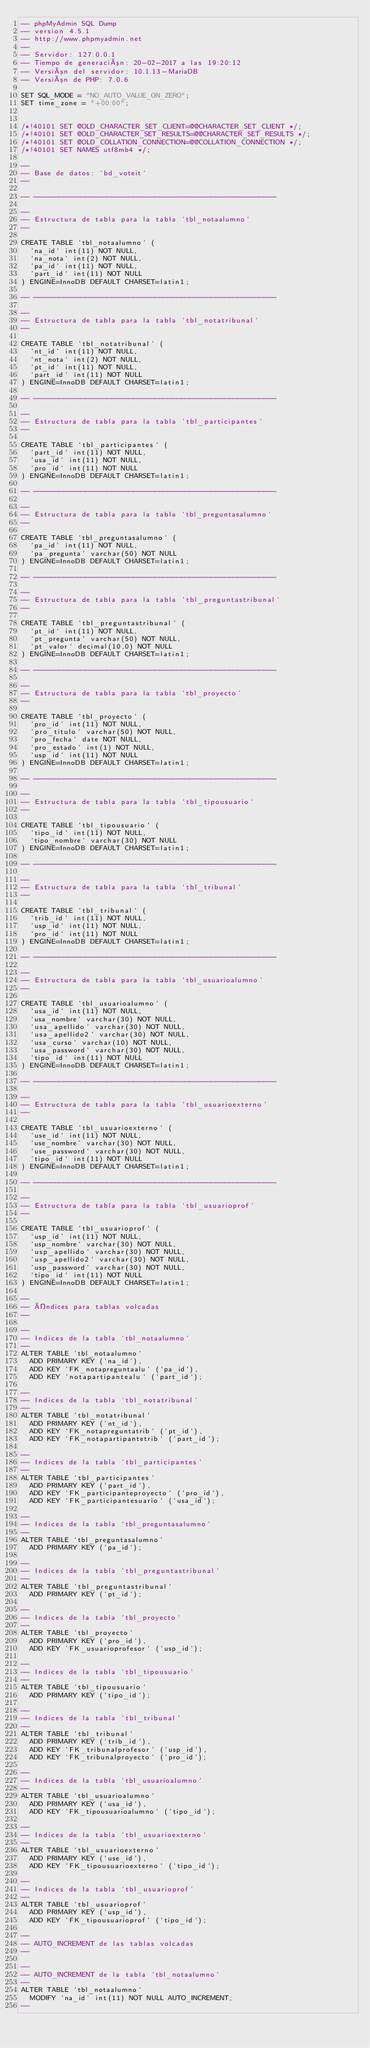<code> <loc_0><loc_0><loc_500><loc_500><_SQL_>-- phpMyAdmin SQL Dump
-- version 4.5.1
-- http://www.phpmyadmin.net
--
-- Servidor: 127.0.0.1
-- Tiempo de generación: 20-02-2017 a las 19:20:12
-- Versión del servidor: 10.1.13-MariaDB
-- Versión de PHP: 7.0.6

SET SQL_MODE = "NO_AUTO_VALUE_ON_ZERO";
SET time_zone = "+00:00";


/*!40101 SET @OLD_CHARACTER_SET_CLIENT=@@CHARACTER_SET_CLIENT */;
/*!40101 SET @OLD_CHARACTER_SET_RESULTS=@@CHARACTER_SET_RESULTS */;
/*!40101 SET @OLD_COLLATION_CONNECTION=@@COLLATION_CONNECTION */;
/*!40101 SET NAMES utf8mb4 */;

--
-- Base de datos: `bd_voteit`
--

-- --------------------------------------------------------

--
-- Estructura de tabla para la tabla `tbl_notaalumno`
--

CREATE TABLE `tbl_notaalumno` (
  `na_id` int(11) NOT NULL,
  `na_nota` int(2) NOT NULL,
  `pa_id` int(11) NOT NULL,
  `part_id` int(11) NOT NULL
) ENGINE=InnoDB DEFAULT CHARSET=latin1;

-- --------------------------------------------------------

--
-- Estructura de tabla para la tabla `tbl_notatribunal`
--

CREATE TABLE `tbl_notatribunal` (
  `nt_id` int(11) NOT NULL,
  `nt_nota` int(2) NOT NULL,
  `pt_id` int(11) NOT NULL,
  `part_id` int(11) NOT NULL
) ENGINE=InnoDB DEFAULT CHARSET=latin1;

-- --------------------------------------------------------

--
-- Estructura de tabla para la tabla `tbl_participantes`
--

CREATE TABLE `tbl_participantes` (
  `part_id` int(11) NOT NULL,
  `usa_id` int(11) NOT NULL,
  `pro_id` int(11) NOT NULL
) ENGINE=InnoDB DEFAULT CHARSET=latin1;

-- --------------------------------------------------------

--
-- Estructura de tabla para la tabla `tbl_preguntasalumno`
--

CREATE TABLE `tbl_preguntasalumno` (
  `pa_id` int(11) NOT NULL,
  `pa_pregunta` varchar(50) NOT NULL
) ENGINE=InnoDB DEFAULT CHARSET=latin1;

-- --------------------------------------------------------

--
-- Estructura de tabla para la tabla `tbl_preguntastribunal`
--

CREATE TABLE `tbl_preguntastribunal` (
  `pt_id` int(11) NOT NULL,
  `pt_pregunta` varchar(50) NOT NULL,
  `pt_valor` decimal(10,0) NOT NULL
) ENGINE=InnoDB DEFAULT CHARSET=latin1;

-- --------------------------------------------------------

--
-- Estructura de tabla para la tabla `tbl_proyecto`
--

CREATE TABLE `tbl_proyecto` (
  `pro_id` int(11) NOT NULL,
  `pro_titulo` varchar(50) NOT NULL,
  `pro_fecha` date NOT NULL,
  `pro_estado` int(1) NOT NULL,
  `usp_id` int(11) NOT NULL
) ENGINE=InnoDB DEFAULT CHARSET=latin1;

-- --------------------------------------------------------

--
-- Estructura de tabla para la tabla `tbl_tipousuario`
--

CREATE TABLE `tbl_tipousuario` (
  `tipo_id` int(11) NOT NULL,
  `tipo_nombre` varchar(30) NOT NULL
) ENGINE=InnoDB DEFAULT CHARSET=latin1;

-- --------------------------------------------------------

--
-- Estructura de tabla para la tabla `tbl_tribunal`
--

CREATE TABLE `tbl_tribunal` (
  `trib_id` int(11) NOT NULL,
  `usp_id` int(11) NOT NULL,
  `pro_id` int(11) NOT NULL
) ENGINE=InnoDB DEFAULT CHARSET=latin1;

-- --------------------------------------------------------

--
-- Estructura de tabla para la tabla `tbl_usuarioalumno`
--

CREATE TABLE `tbl_usuarioalumno` (
  `usa_id` int(11) NOT NULL,
  `usa_nombre` varchar(30) NOT NULL,
  `usa_apellido` varchar(30) NOT NULL,
  `usa_apellido2` varchar(30) NOT NULL,
  `usa_curso` varchar(10) NOT NULL,
  `usa_password` varchar(30) NOT NULL,
  `tipo_id` int(11) NOT NULL
) ENGINE=InnoDB DEFAULT CHARSET=latin1;

-- --------------------------------------------------------

--
-- Estructura de tabla para la tabla `tbl_usuarioexterno`
--

CREATE TABLE `tbl_usuarioexterno` (
  `use_id` int(11) NOT NULL,
  `use_nombre` varchar(30) NOT NULL,
  `use_password` varchar(30) NOT NULL,
  `tipo_id` int(11) NOT NULL
) ENGINE=InnoDB DEFAULT CHARSET=latin1;

-- --------------------------------------------------------

--
-- Estructura de tabla para la tabla `tbl_usuarioprof`
--

CREATE TABLE `tbl_usuarioprof` (
  `usp_id` int(11) NOT NULL,
  `usp_nombre` varchar(30) NOT NULL,
  `usp_apellido` varchar(30) NOT NULL,
  `usp_apellido2` varchar(30) NOT NULL,
  `usp_password` varchar(30) NOT NULL,
  `tipo_id` int(11) NOT NULL
) ENGINE=InnoDB DEFAULT CHARSET=latin1;

--
-- Índices para tablas volcadas
--

--
-- Indices de la tabla `tbl_notaalumno`
--
ALTER TABLE `tbl_notaalumno`
  ADD PRIMARY KEY (`na_id`),
  ADD KEY `FK_notapreguntaalu` (`pa_id`),
  ADD KEY `notapartipantealu` (`part_id`);

--
-- Indices de la tabla `tbl_notatribunal`
--
ALTER TABLE `tbl_notatribunal`
  ADD PRIMARY KEY (`nt_id`),
  ADD KEY `FK_notapreguntatrib` (`pt_id`),
  ADD KEY `FK_notapartipantetrib` (`part_id`);

--
-- Indices de la tabla `tbl_participantes`
--
ALTER TABLE `tbl_participantes`
  ADD PRIMARY KEY (`part_id`),
  ADD KEY `FK_participanteproyecto` (`pro_id`),
  ADD KEY `FK_participantesuario` (`usa_id`);

--
-- Indices de la tabla `tbl_preguntasalumno`
--
ALTER TABLE `tbl_preguntasalumno`
  ADD PRIMARY KEY (`pa_id`);

--
-- Indices de la tabla `tbl_preguntastribunal`
--
ALTER TABLE `tbl_preguntastribunal`
  ADD PRIMARY KEY (`pt_id`);

--
-- Indices de la tabla `tbl_proyecto`
--
ALTER TABLE `tbl_proyecto`
  ADD PRIMARY KEY (`pro_id`),
  ADD KEY `FK_usuarioprofesor` (`usp_id`);

--
-- Indices de la tabla `tbl_tipousuario`
--
ALTER TABLE `tbl_tipousuario`
  ADD PRIMARY KEY (`tipo_id`);

--
-- Indices de la tabla `tbl_tribunal`
--
ALTER TABLE `tbl_tribunal`
  ADD PRIMARY KEY (`trib_id`),
  ADD KEY `FK_tribunalprofesor` (`usp_id`),
  ADD KEY `FK_tribunalproyecto` (`pro_id`);

--
-- Indices de la tabla `tbl_usuarioalumno`
--
ALTER TABLE `tbl_usuarioalumno`
  ADD PRIMARY KEY (`usa_id`),
  ADD KEY `FK_tipousuarioalumno` (`tipo_id`);

--
-- Indices de la tabla `tbl_usuarioexterno`
--
ALTER TABLE `tbl_usuarioexterno`
  ADD PRIMARY KEY (`use_id`),
  ADD KEY `FK_tipousuarioexterno` (`tipo_id`);

--
-- Indices de la tabla `tbl_usuarioprof`
--
ALTER TABLE `tbl_usuarioprof`
  ADD PRIMARY KEY (`usp_id`),
  ADD KEY `FK_tipousuarioprof` (`tipo_id`);

--
-- AUTO_INCREMENT de las tablas volcadas
--

--
-- AUTO_INCREMENT de la tabla `tbl_notaalumno`
--
ALTER TABLE `tbl_notaalumno`
  MODIFY `na_id` int(11) NOT NULL AUTO_INCREMENT;
--</code> 